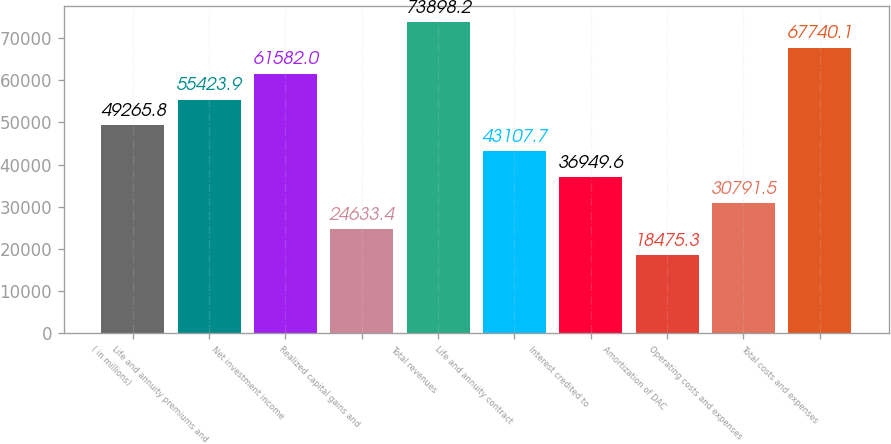Convert chart to OTSL. <chart><loc_0><loc_0><loc_500><loc_500><bar_chart><fcel>( in millions)<fcel>Life and annuity premiums and<fcel>Net investment income<fcel>Realized capital gains and<fcel>Total revenues<fcel>Life and annuity contract<fcel>Interest credited to<fcel>Amortization of DAC<fcel>Operating costs and expenses<fcel>Total costs and expenses<nl><fcel>49265.8<fcel>55423.9<fcel>61582<fcel>24633.4<fcel>73898.2<fcel>43107.7<fcel>36949.6<fcel>18475.3<fcel>30791.5<fcel>67740.1<nl></chart> 